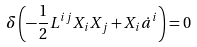<formula> <loc_0><loc_0><loc_500><loc_500>\delta \left ( - \frac { 1 } { 2 } L ^ { i j } X _ { i } X _ { j } + X _ { i } \dot { a } ^ { i } \right ) = 0</formula> 